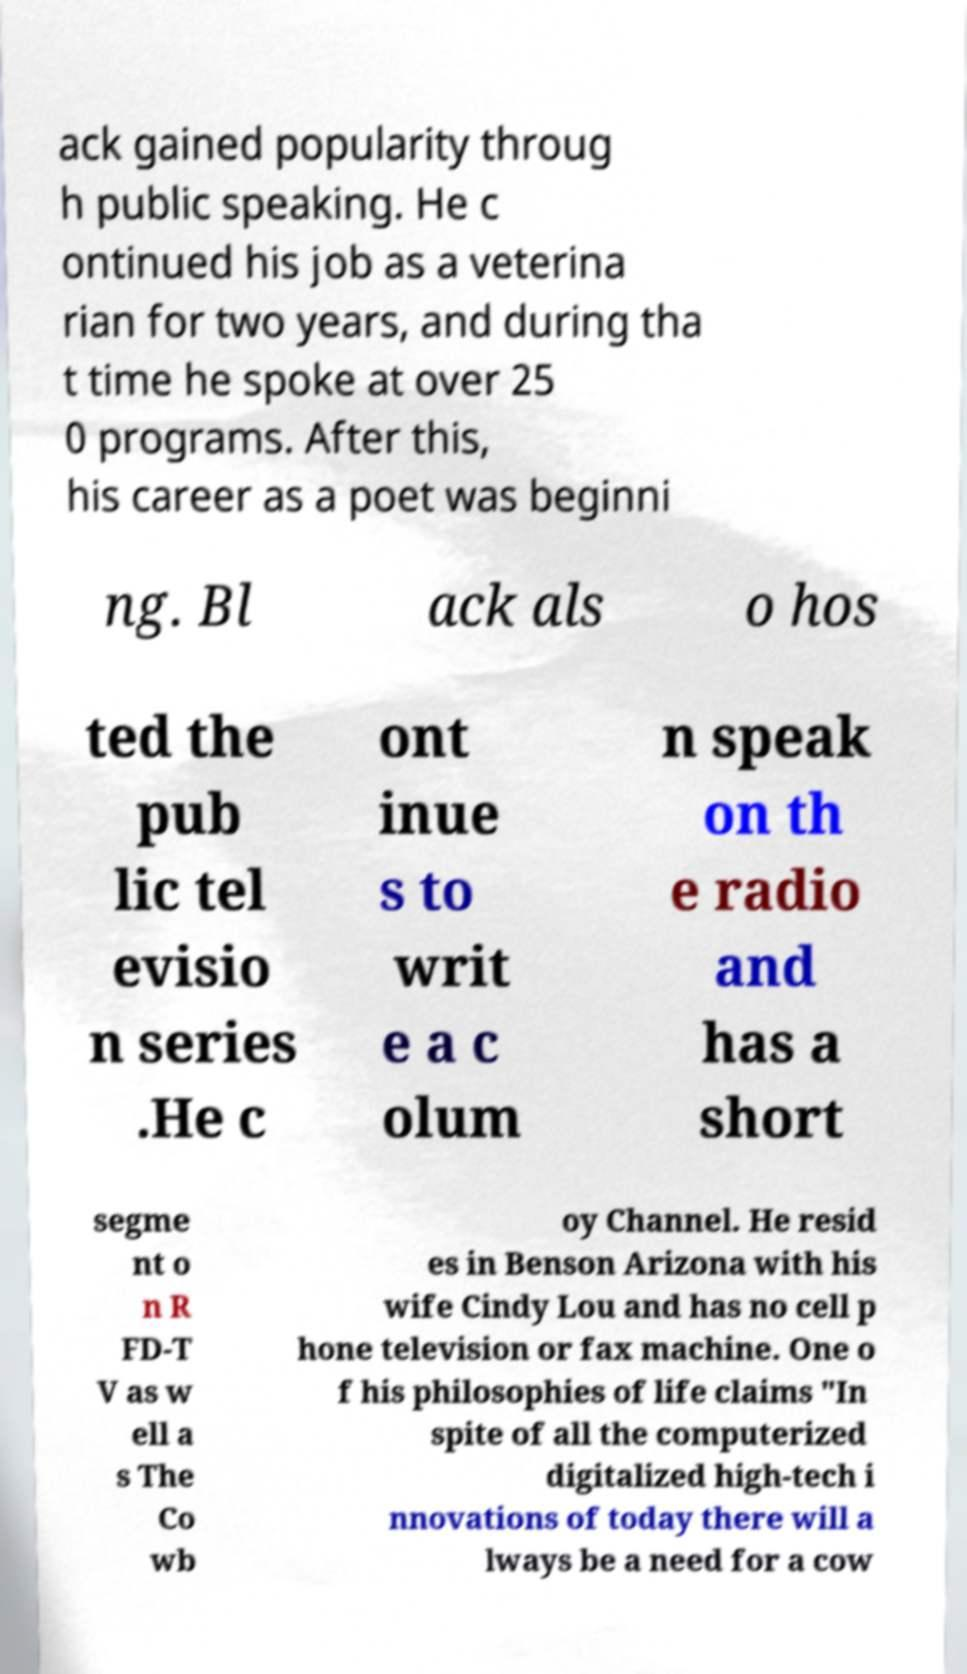Please identify and transcribe the text found in this image. ack gained popularity throug h public speaking. He c ontinued his job as a veterina rian for two years, and during tha t time he spoke at over 25 0 programs. After this, his career as a poet was beginni ng. Bl ack als o hos ted the pub lic tel evisio n series .He c ont inue s to writ e a c olum n speak on th e radio and has a short segme nt o n R FD-T V as w ell a s The Co wb oy Channel. He resid es in Benson Arizona with his wife Cindy Lou and has no cell p hone television or fax machine. One o f his philosophies of life claims "In spite of all the computerized digitalized high-tech i nnovations of today there will a lways be a need for a cow 